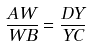Convert formula to latex. <formula><loc_0><loc_0><loc_500><loc_500>\frac { A W } { W B } = \frac { D Y } { Y C }</formula> 